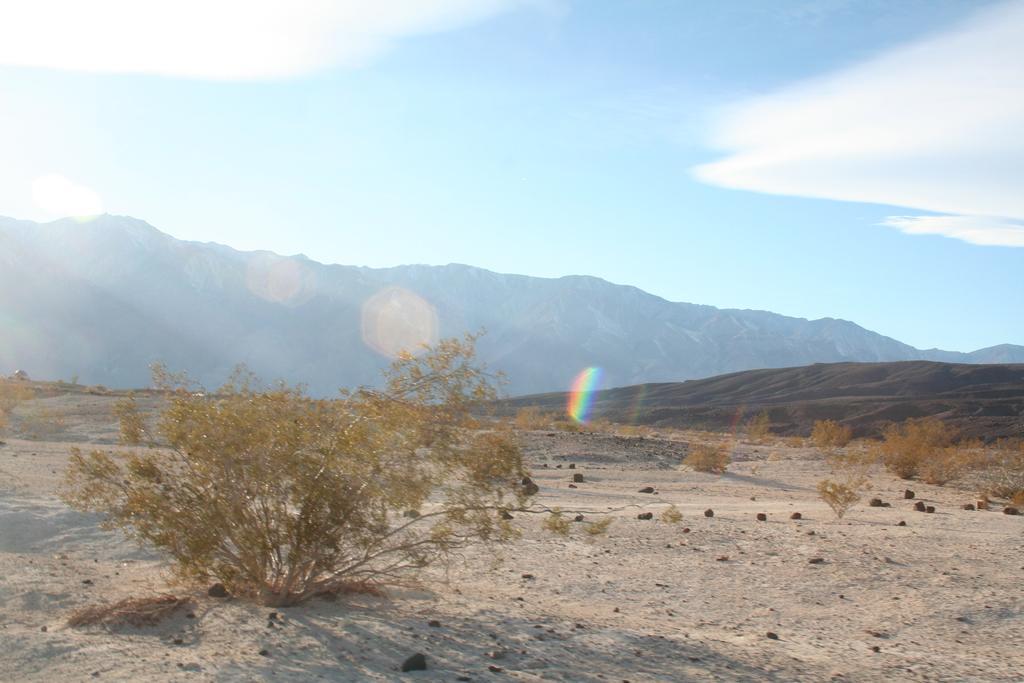Can you describe this image briefly? In this image I can see the land on which there are few plants and in the background I can see the mountains and the sky. 